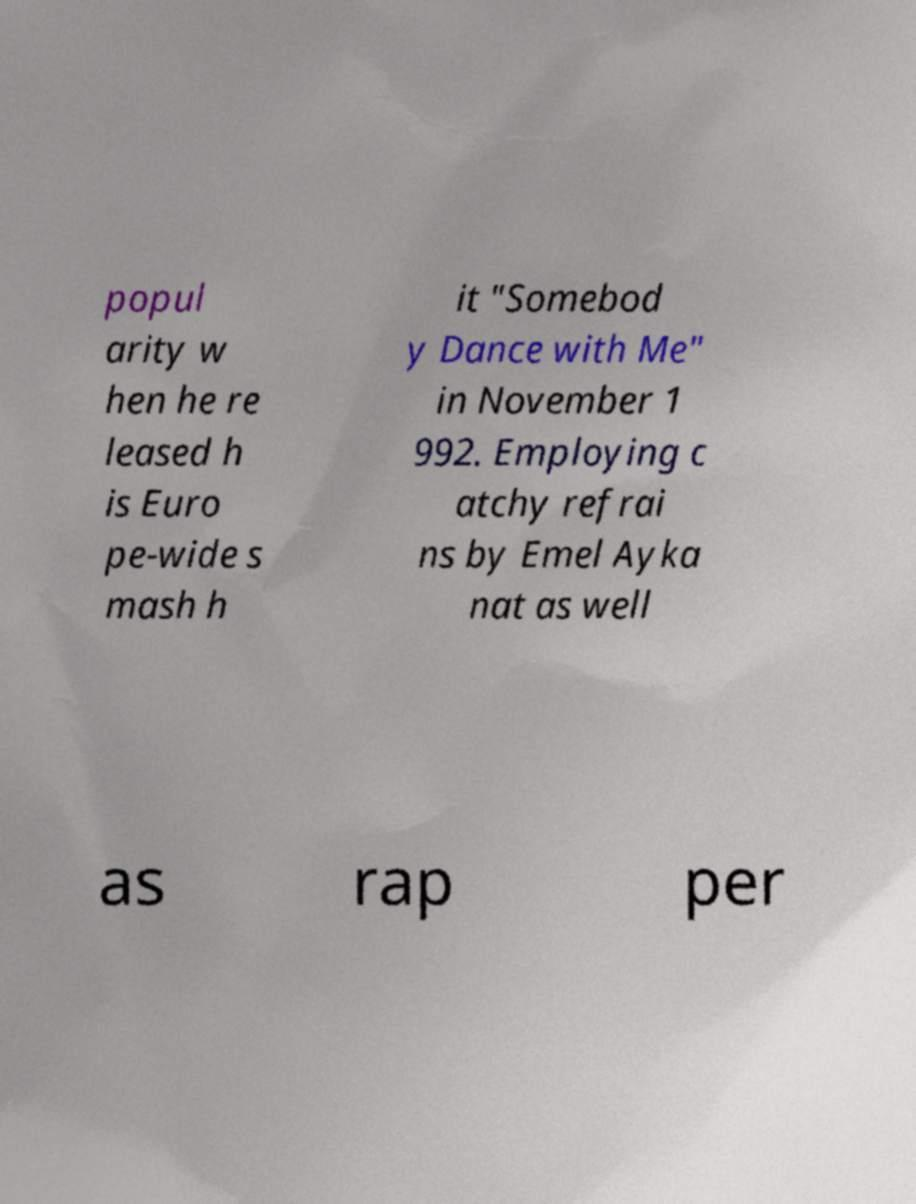I need the written content from this picture converted into text. Can you do that? popul arity w hen he re leased h is Euro pe-wide s mash h it "Somebod y Dance with Me" in November 1 992. Employing c atchy refrai ns by Emel Ayka nat as well as rap per 